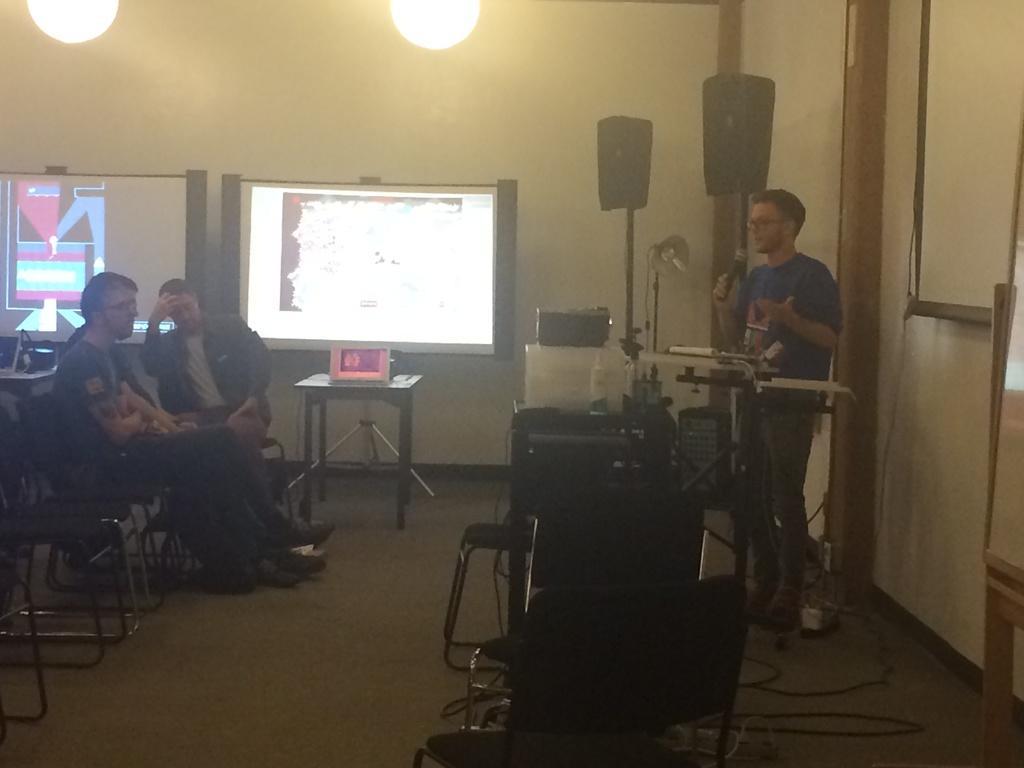Can you describe this image briefly? In this picture there is a person standing and speaking in front of a mic in the right corner and there are some other objects in front of him and there are three persons sitting in chairs in the left corner and there are some other objects,lights and speakers in the background. 